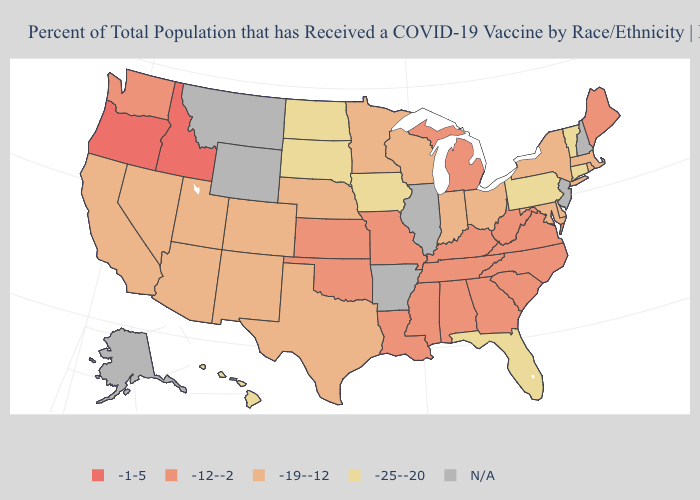Among the states that border Massachusetts , does Vermont have the lowest value?
Quick response, please. Yes. Name the states that have a value in the range -25--20?
Write a very short answer. Connecticut, Florida, Hawaii, Iowa, North Dakota, Pennsylvania, South Dakota, Vermont. What is the highest value in the USA?
Quick response, please. -1-5. What is the lowest value in the USA?
Write a very short answer. -25--20. What is the value of Nevada?
Quick response, please. -19--12. Does Iowa have the lowest value in the MidWest?
Answer briefly. Yes. Name the states that have a value in the range -19--12?
Write a very short answer. Arizona, California, Colorado, Delaware, Indiana, Maryland, Massachusetts, Minnesota, Nebraska, Nevada, New Mexico, New York, Ohio, Rhode Island, Texas, Utah, Wisconsin. What is the value of Texas?
Short answer required. -19--12. Does the first symbol in the legend represent the smallest category?
Give a very brief answer. No. Among the states that border Indiana , which have the lowest value?
Be succinct. Ohio. What is the value of Colorado?
Be succinct. -19--12. What is the value of Nebraska?
Concise answer only. -19--12. What is the value of Louisiana?
Short answer required. -12--2. Name the states that have a value in the range -19--12?
Give a very brief answer. Arizona, California, Colorado, Delaware, Indiana, Maryland, Massachusetts, Minnesota, Nebraska, Nevada, New Mexico, New York, Ohio, Rhode Island, Texas, Utah, Wisconsin. What is the highest value in the MidWest ?
Short answer required. -12--2. 